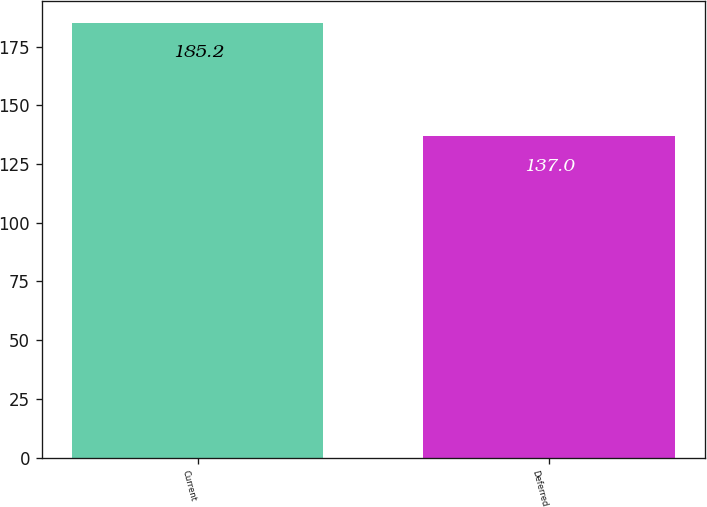<chart> <loc_0><loc_0><loc_500><loc_500><bar_chart><fcel>Current<fcel>Deferred<nl><fcel>185.2<fcel>137<nl></chart> 